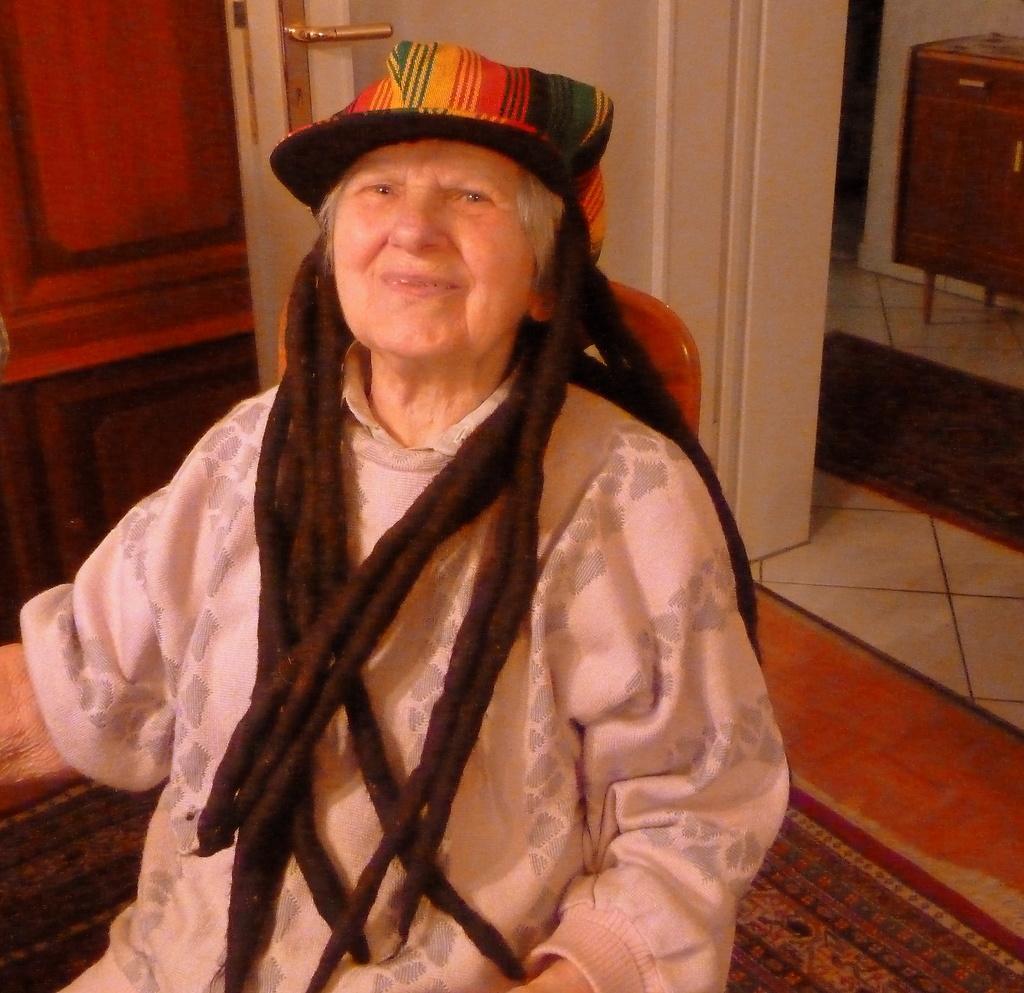Describe this image in one or two sentences. In this image we can see an old person sitting on the chair. In the background of the image there is a wall, door and other objects. 